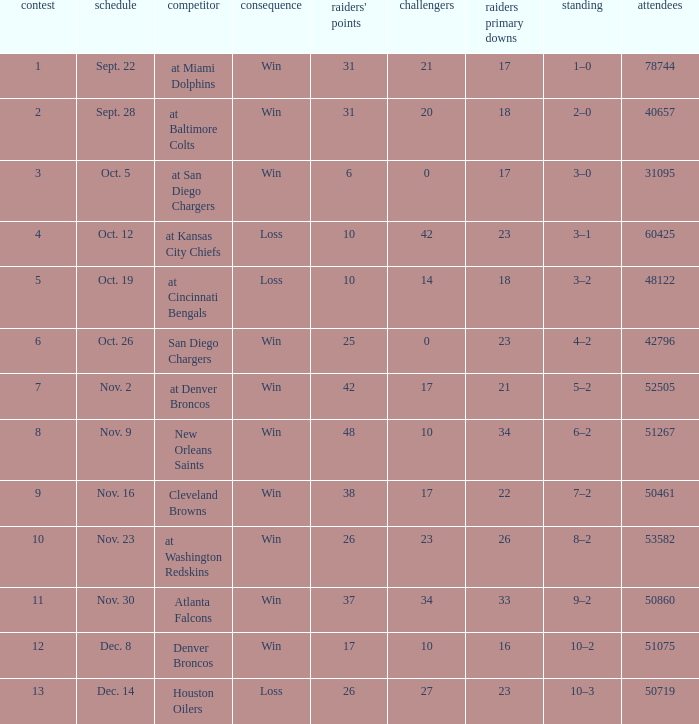How many opponents played 1 game with a result win? 21.0. 